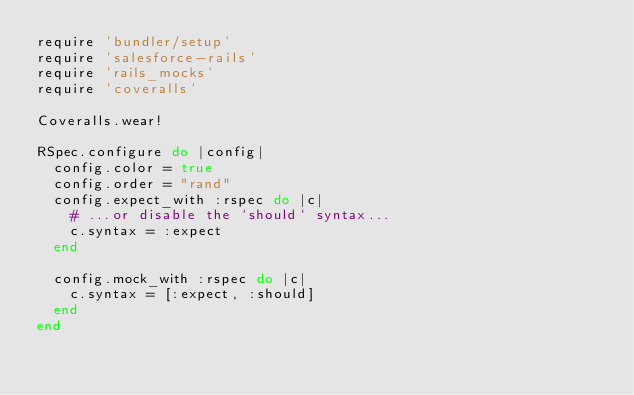Convert code to text. <code><loc_0><loc_0><loc_500><loc_500><_Ruby_>require 'bundler/setup'
require 'salesforce-rails'
require 'rails_mocks'
require 'coveralls'

Coveralls.wear!

RSpec.configure do |config|
  config.color = true
  config.order = "rand"
  config.expect_with :rspec do |c|
    # ...or disable the `should` syntax...
    c.syntax = :expect
  end

  config.mock_with :rspec do |c|
    c.syntax = [:expect, :should]
  end
end</code> 